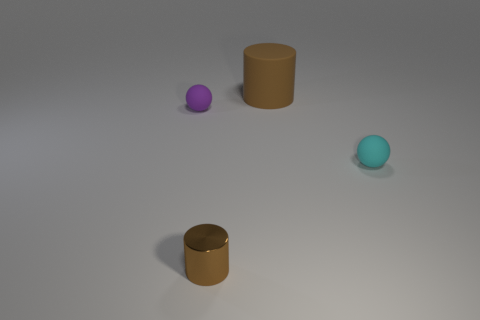Is the number of small cyan rubber spheres left of the shiny thing the same as the number of small purple matte spheres?
Keep it short and to the point. No. What number of brown matte things are on the right side of the cyan rubber thing?
Make the answer very short. 0. The brown metal cylinder has what size?
Offer a terse response. Small. There is a big object that is the same material as the cyan sphere; what is its color?
Give a very brief answer. Brown. How many purple things have the same size as the brown metallic thing?
Keep it short and to the point. 1. Do the ball on the right side of the small brown shiny cylinder and the tiny cylinder have the same material?
Provide a short and direct response. No. Is the number of tiny brown metallic cylinders right of the big brown cylinder less than the number of tiny purple spheres?
Offer a very short reply. Yes. What is the shape of the rubber object to the left of the rubber cylinder?
Provide a short and direct response. Sphere. There is a cyan object that is the same size as the brown shiny cylinder; what shape is it?
Make the answer very short. Sphere. Are there any purple matte things of the same shape as the cyan object?
Provide a short and direct response. Yes. 